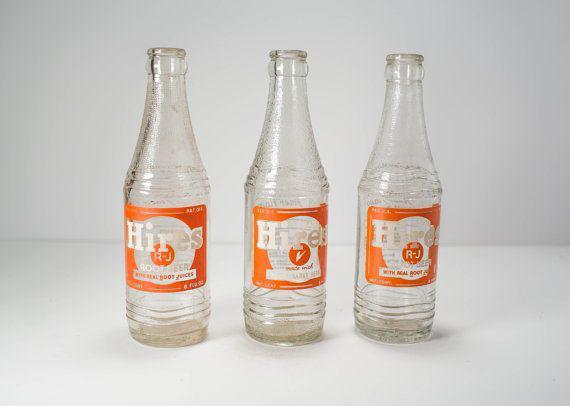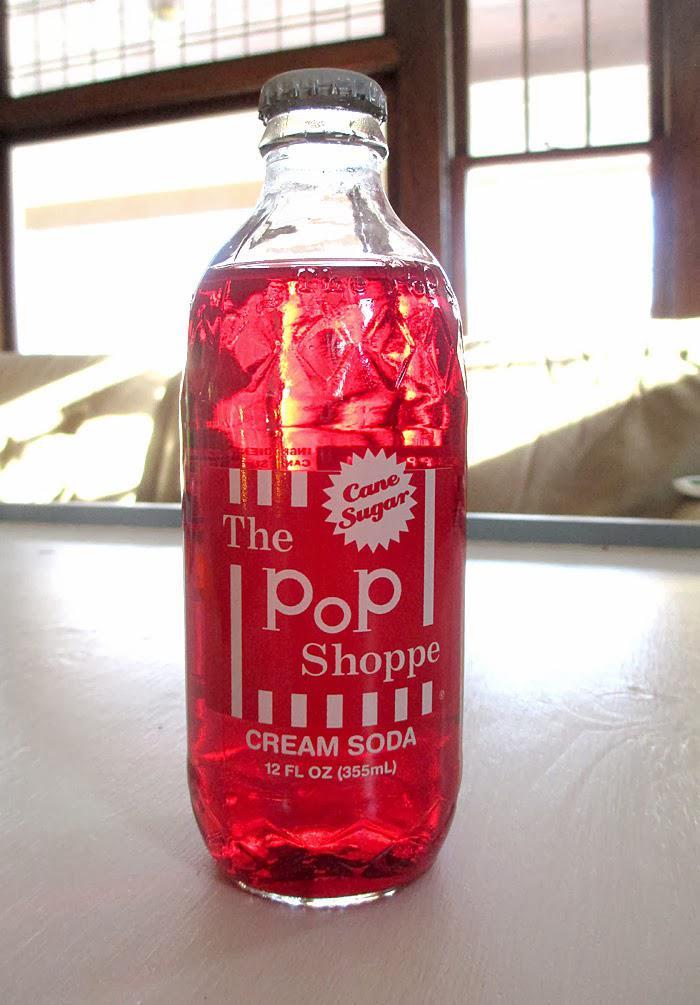The first image is the image on the left, the second image is the image on the right. Analyze the images presented: Is the assertion "the left and right image contains the same number of glass bottles." valid? Answer yes or no. No. The first image is the image on the left, the second image is the image on the right. Given the left and right images, does the statement "there are two glass containers in the image pair" hold true? Answer yes or no. No. 